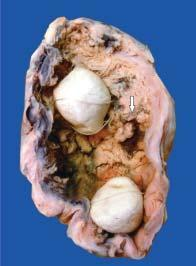what does the lumen of the gallbladder contain?
Answer the question using a single word or phrase. Irregular 